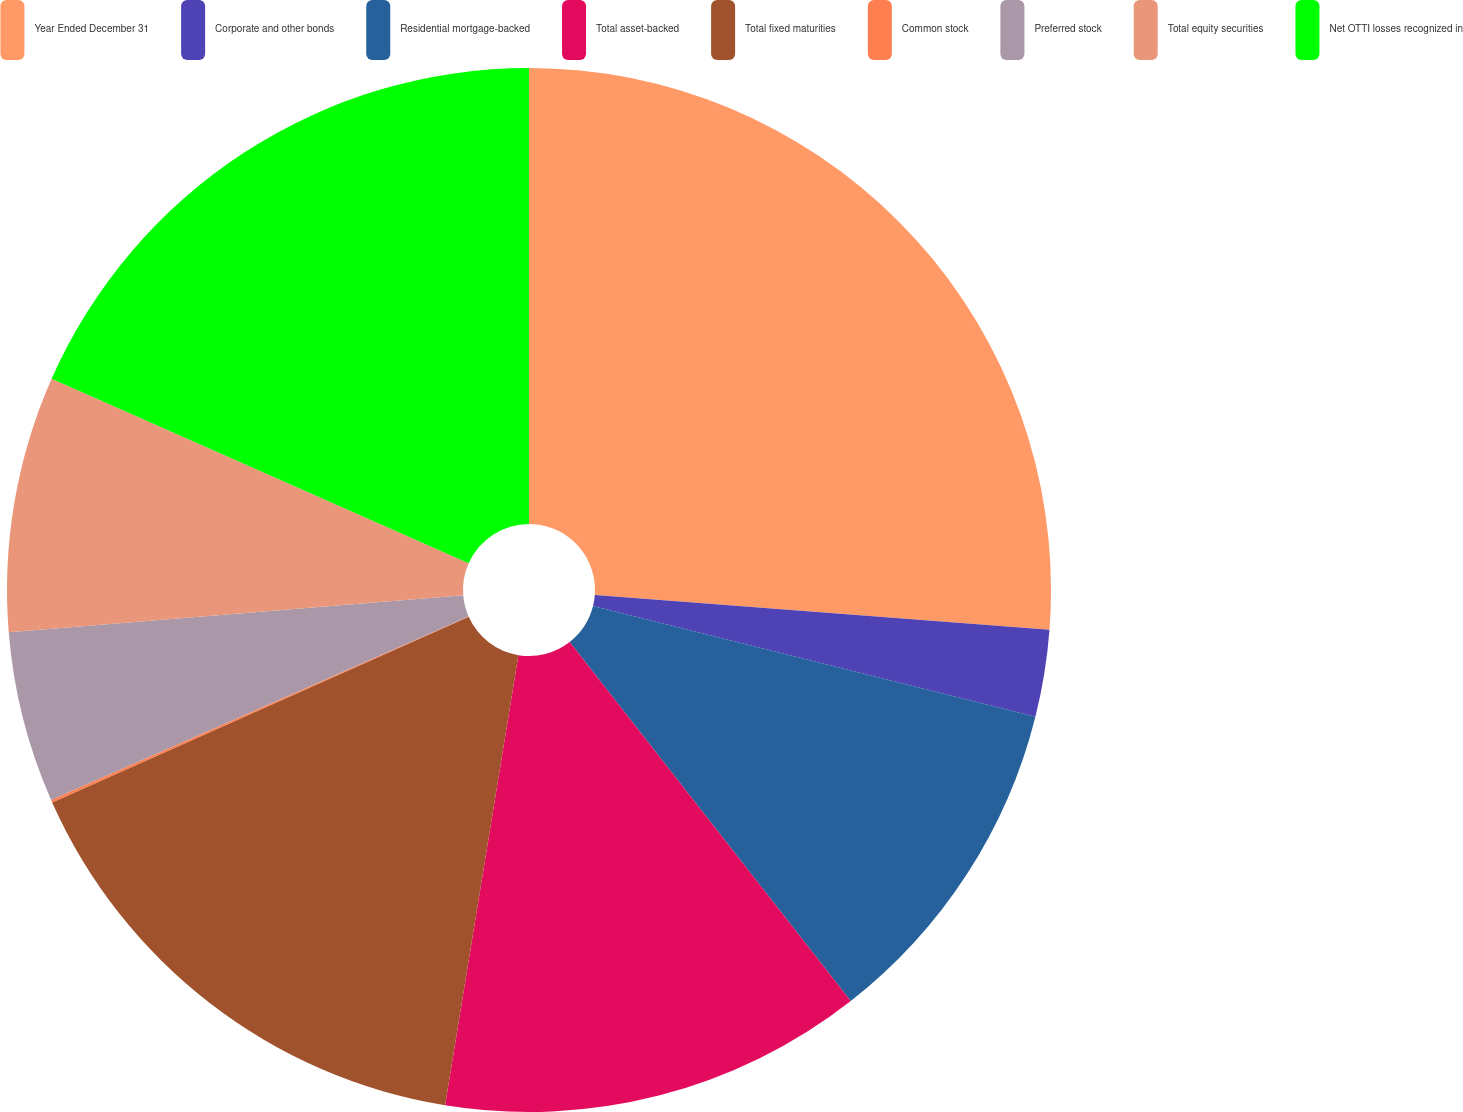<chart> <loc_0><loc_0><loc_500><loc_500><pie_chart><fcel>Year Ended December 31<fcel>Corporate and other bonds<fcel>Residential mortgage-backed<fcel>Total asset-backed<fcel>Total fixed maturities<fcel>Common stock<fcel>Preferred stock<fcel>Total equity securities<fcel>Net OTTI losses recognized in<nl><fcel>26.21%<fcel>2.69%<fcel>10.53%<fcel>13.14%<fcel>15.76%<fcel>0.08%<fcel>5.3%<fcel>7.92%<fcel>18.37%<nl></chart> 